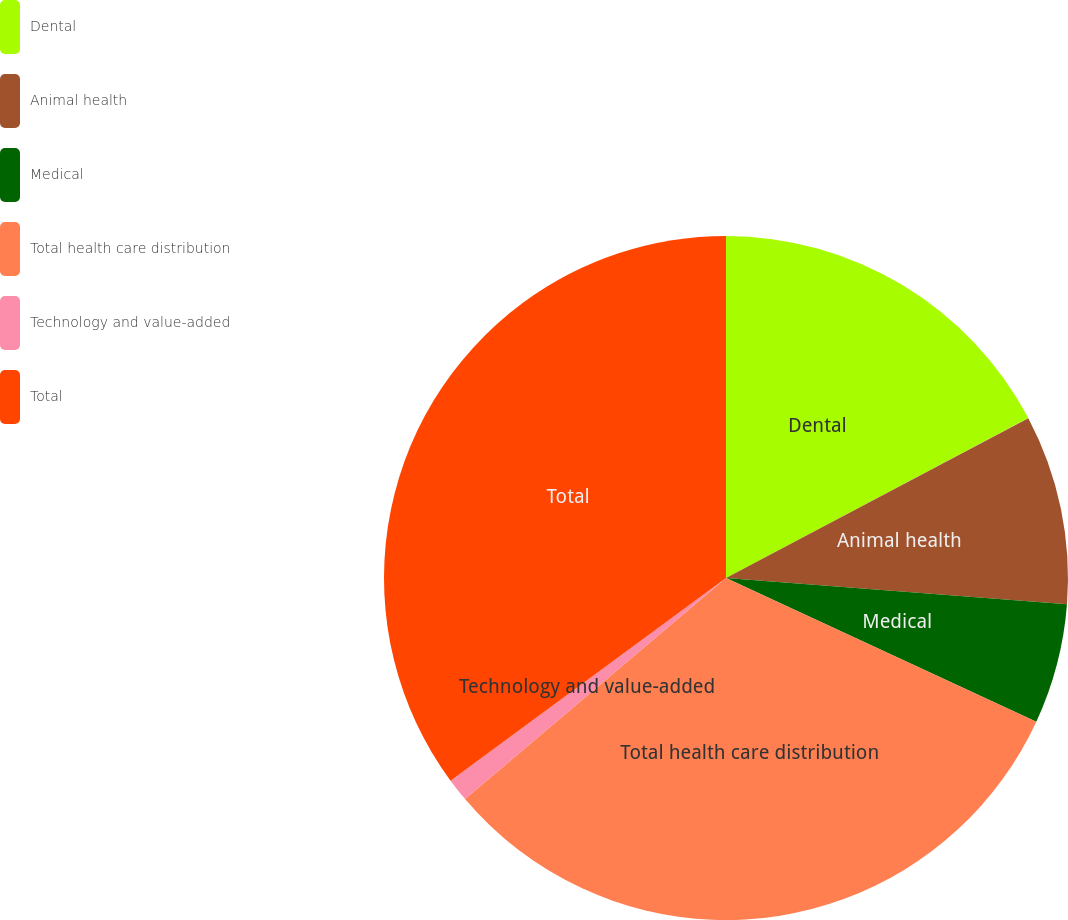<chart> <loc_0><loc_0><loc_500><loc_500><pie_chart><fcel>Dental<fcel>Animal health<fcel>Medical<fcel>Total health care distribution<fcel>Technology and value-added<fcel>Total<nl><fcel>17.26%<fcel>8.97%<fcel>5.68%<fcel>31.91%<fcel>1.09%<fcel>35.1%<nl></chart> 